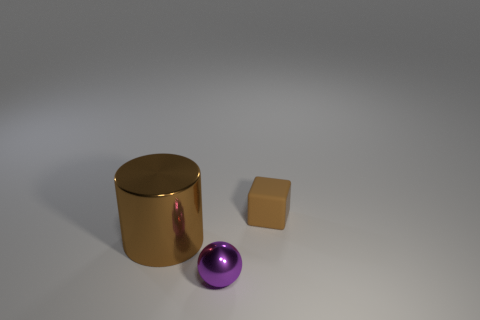What is the shape of the tiny thing behind the small object on the left side of the thing right of the tiny metal thing?
Your response must be concise. Cube. Are the brown object that is to the right of the large thing and the tiny thing in front of the big brown shiny object made of the same material?
Give a very brief answer. No. Is there anything else that is the same size as the brown rubber object?
Your answer should be very brief. Yes. Do the brown object that is on the left side of the rubber cube and the metal object that is in front of the big brown cylinder have the same shape?
Give a very brief answer. No. Is the number of small rubber cubes that are behind the matte thing less than the number of brown cubes that are on the left side of the large brown cylinder?
Offer a very short reply. No. How many other objects are the same shape as the big object?
Keep it short and to the point. 0. There is a object that is the same material as the big brown cylinder; what shape is it?
Make the answer very short. Sphere. What is the color of the object that is behind the tiny purple shiny object and in front of the small brown matte object?
Offer a terse response. Brown. Are the object to the right of the small purple metallic object and the tiny sphere made of the same material?
Your answer should be compact. No. Is the number of large brown cylinders that are right of the brown shiny object less than the number of big gray rubber things?
Make the answer very short. No. 